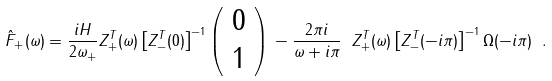Convert formula to latex. <formula><loc_0><loc_0><loc_500><loc_500>\hat { F } _ { + } ( \omega ) = \frac { i H } { 2 \omega _ { + } } Z _ { + } ^ { T } ( \omega ) \left [ Z _ { - } ^ { T } ( 0 ) \right ] ^ { - 1 } \left ( \begin{array} { c } 0 \\ 1 \end{array} \right ) \, - \frac { 2 \pi i } { \omega + i \pi } \ Z _ { + } ^ { T } ( \omega ) \left [ Z _ { - } ^ { T } ( - i \pi ) \right ] ^ { - 1 } \Omega ( - i \pi ) \ .</formula> 